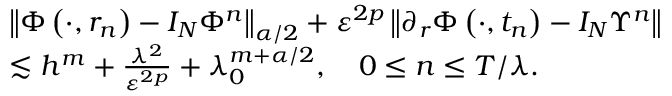Convert formula to latex. <formula><loc_0><loc_0><loc_500><loc_500>\begin{array} { r l } & { \left \| \Phi \left ( \cdot , r _ { n } \right ) - I _ { N } \Phi ^ { n } \right \| _ { \alpha / 2 } + \varepsilon ^ { 2 p } \left \| \partial _ { r } \Phi \left ( \cdot , t _ { n } \right ) - I _ { N } \Upsilon ^ { n } \right \| } \\ & { \lesssim h ^ { m } + \frac { \lambda ^ { 2 } } { \varepsilon ^ { 2 p } } + \lambda _ { 0 } ^ { m + \alpha / 2 } , \quad 0 \leq n \leq T / { \lambda } . } \end{array}</formula> 